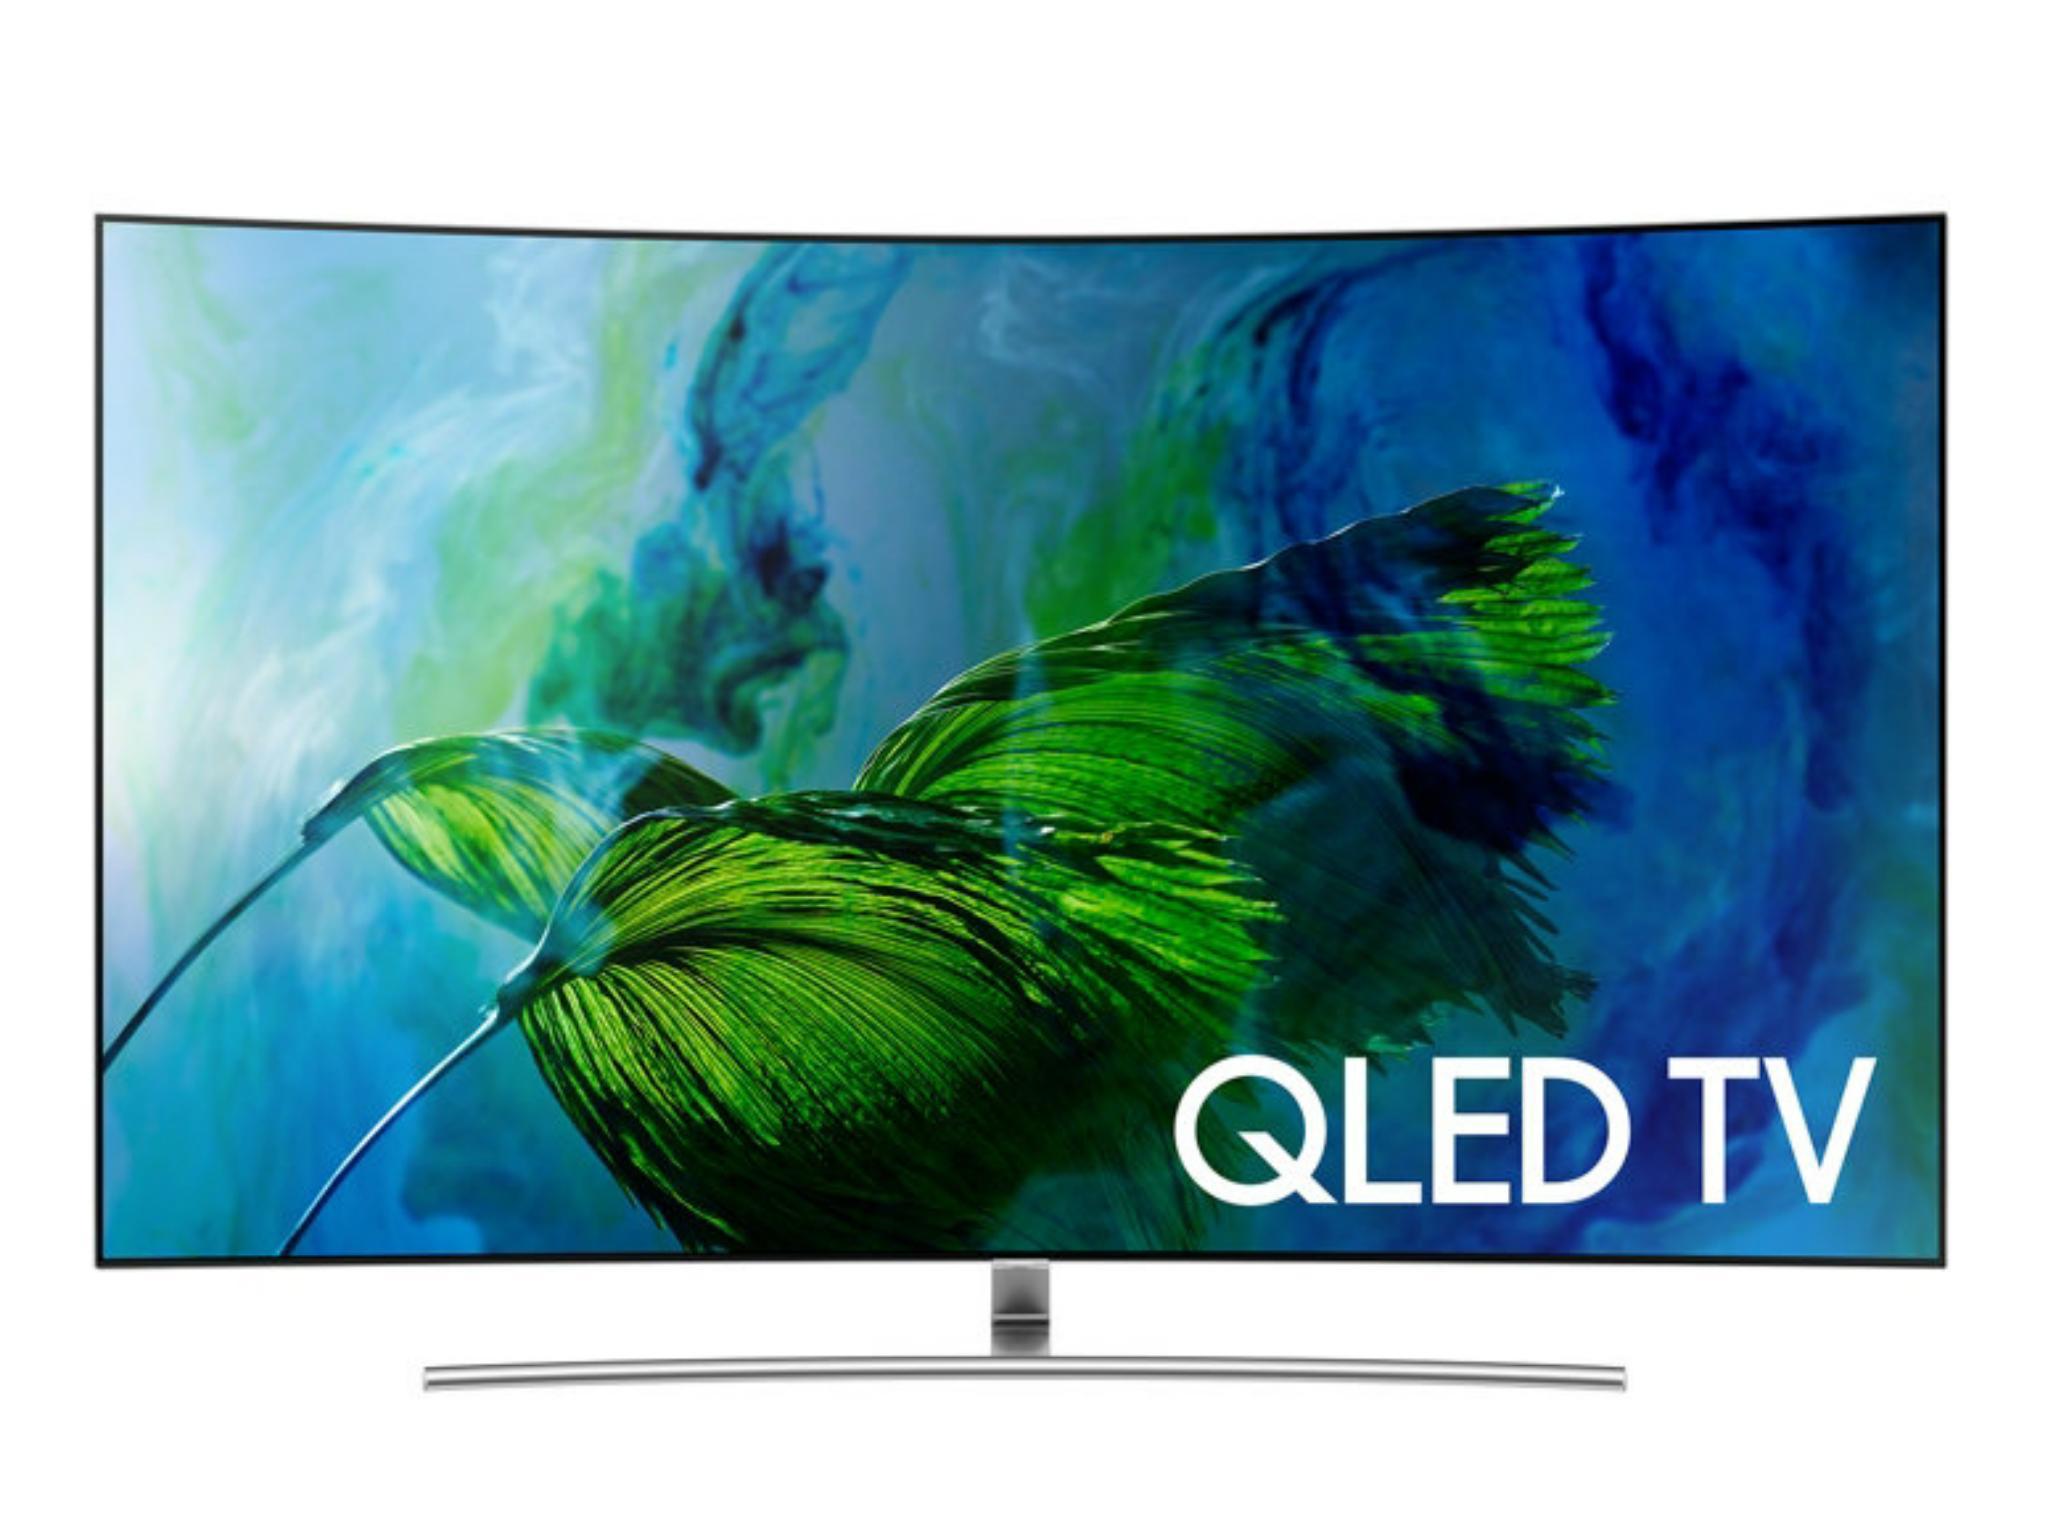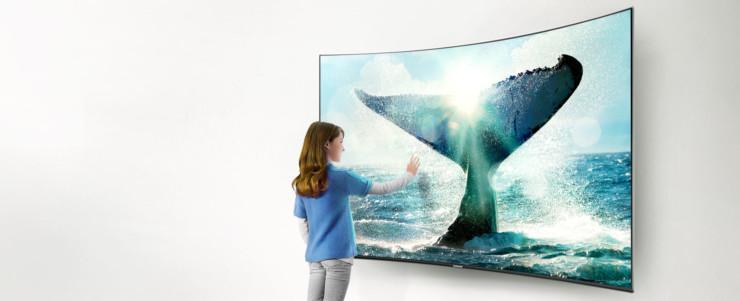The first image is the image on the left, the second image is the image on the right. Given the left and right images, does the statement "Each image contains a single screen, and left and right images feature different pictures on the screens." hold true? Answer yes or no. Yes. The first image is the image on the left, the second image is the image on the right. For the images displayed, is the sentence "there is a curved tv on a metal stand with wording in the corner" factually correct? Answer yes or no. Yes. 